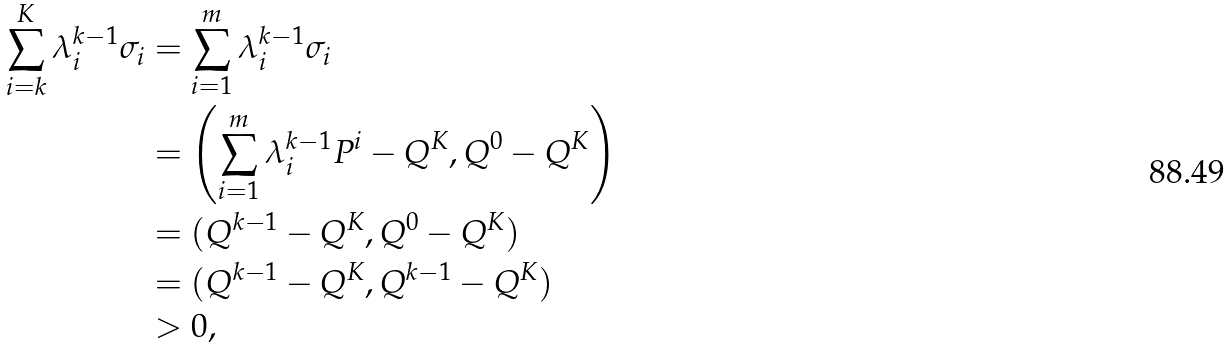Convert formula to latex. <formula><loc_0><loc_0><loc_500><loc_500>\sum _ { i = k } ^ { K } \lambda ^ { k - 1 } _ { i } \sigma _ { i } & = \sum _ { i = 1 } ^ { m } \lambda ^ { k - 1 } _ { i } \sigma _ { i } \\ & = \left ( \sum _ { i = 1 } ^ { m } \lambda ^ { k - 1 } _ { i } P ^ { i } - Q ^ { K } , Q ^ { 0 } - Q ^ { K } \right ) \\ & = ( Q ^ { k - 1 } - Q ^ { K } , Q ^ { 0 } - Q ^ { K } ) \\ & = ( Q ^ { k - 1 } - Q ^ { K } , Q ^ { k - 1 } - Q ^ { K } ) \\ & > 0 ,</formula> 